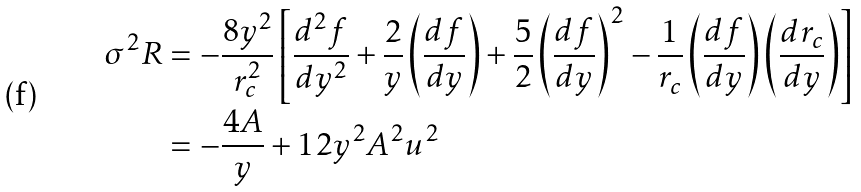<formula> <loc_0><loc_0><loc_500><loc_500>\sigma ^ { 2 } R & = - \frac { 8 y ^ { 2 } } { r _ { c } ^ { 2 } } \left [ \frac { d ^ { 2 } f } { d y ^ { 2 } } + \frac { 2 } { y } \left ( \frac { d f } { d y } \right ) + \frac { 5 } { 2 } \left ( \frac { d f } { d y } \right ) ^ { 2 } - \frac { 1 } { r _ { c } } \left ( \frac { d f } { d y } \right ) \left ( \frac { d r _ { c } } { d y } \right ) \right ] \\ & = - \frac { 4 A } { y } + 1 2 y ^ { 2 } A ^ { 2 } u ^ { 2 }</formula> 